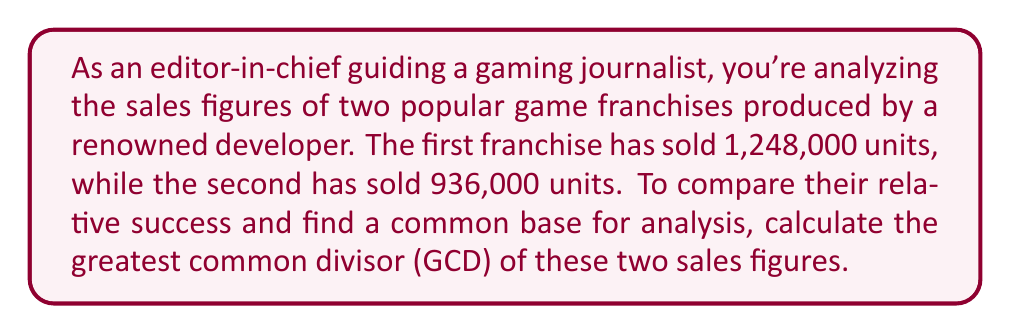Provide a solution to this math problem. To find the greatest common divisor (GCD) of 1,248,000 and 936,000, we'll use the Euclidean algorithm. This method involves repeatedly dividing the larger number by the smaller one and taking the remainder until we reach zero.

Let's start:

1) First, divide 1,248,000 by 936,000:
   $$1,248,000 = 1 \times 936,000 + 312,000$$

2) Now divide 936,000 by 312,000:
   $$936,000 = 3 \times 312,000 + 0$$

Since the remainder is 0, we've found our GCD. It's 312,000.

To verify, let's factor both numbers:

$$1,248,000 = 2^8 \times 3^2 \times 5^3 = 312,000 \times 4$$
$$936,000 = 2^6 \times 3^2 \times 5^3 = 312,000 \times 3$$

Indeed, 312,000 is the largest number that divides both evenly.

This result suggests that for every 4 units sold of the first franchise, 3 units of the second franchise were sold, providing a relative measure of their success.
Answer: The greatest common divisor of 1,248,000 and 936,000 is 312,000. 